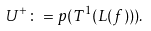Convert formula to latex. <formula><loc_0><loc_0><loc_500><loc_500>& U ^ { + } \colon = p ( T ^ { 1 } ( L ( f ) ) ) .</formula> 